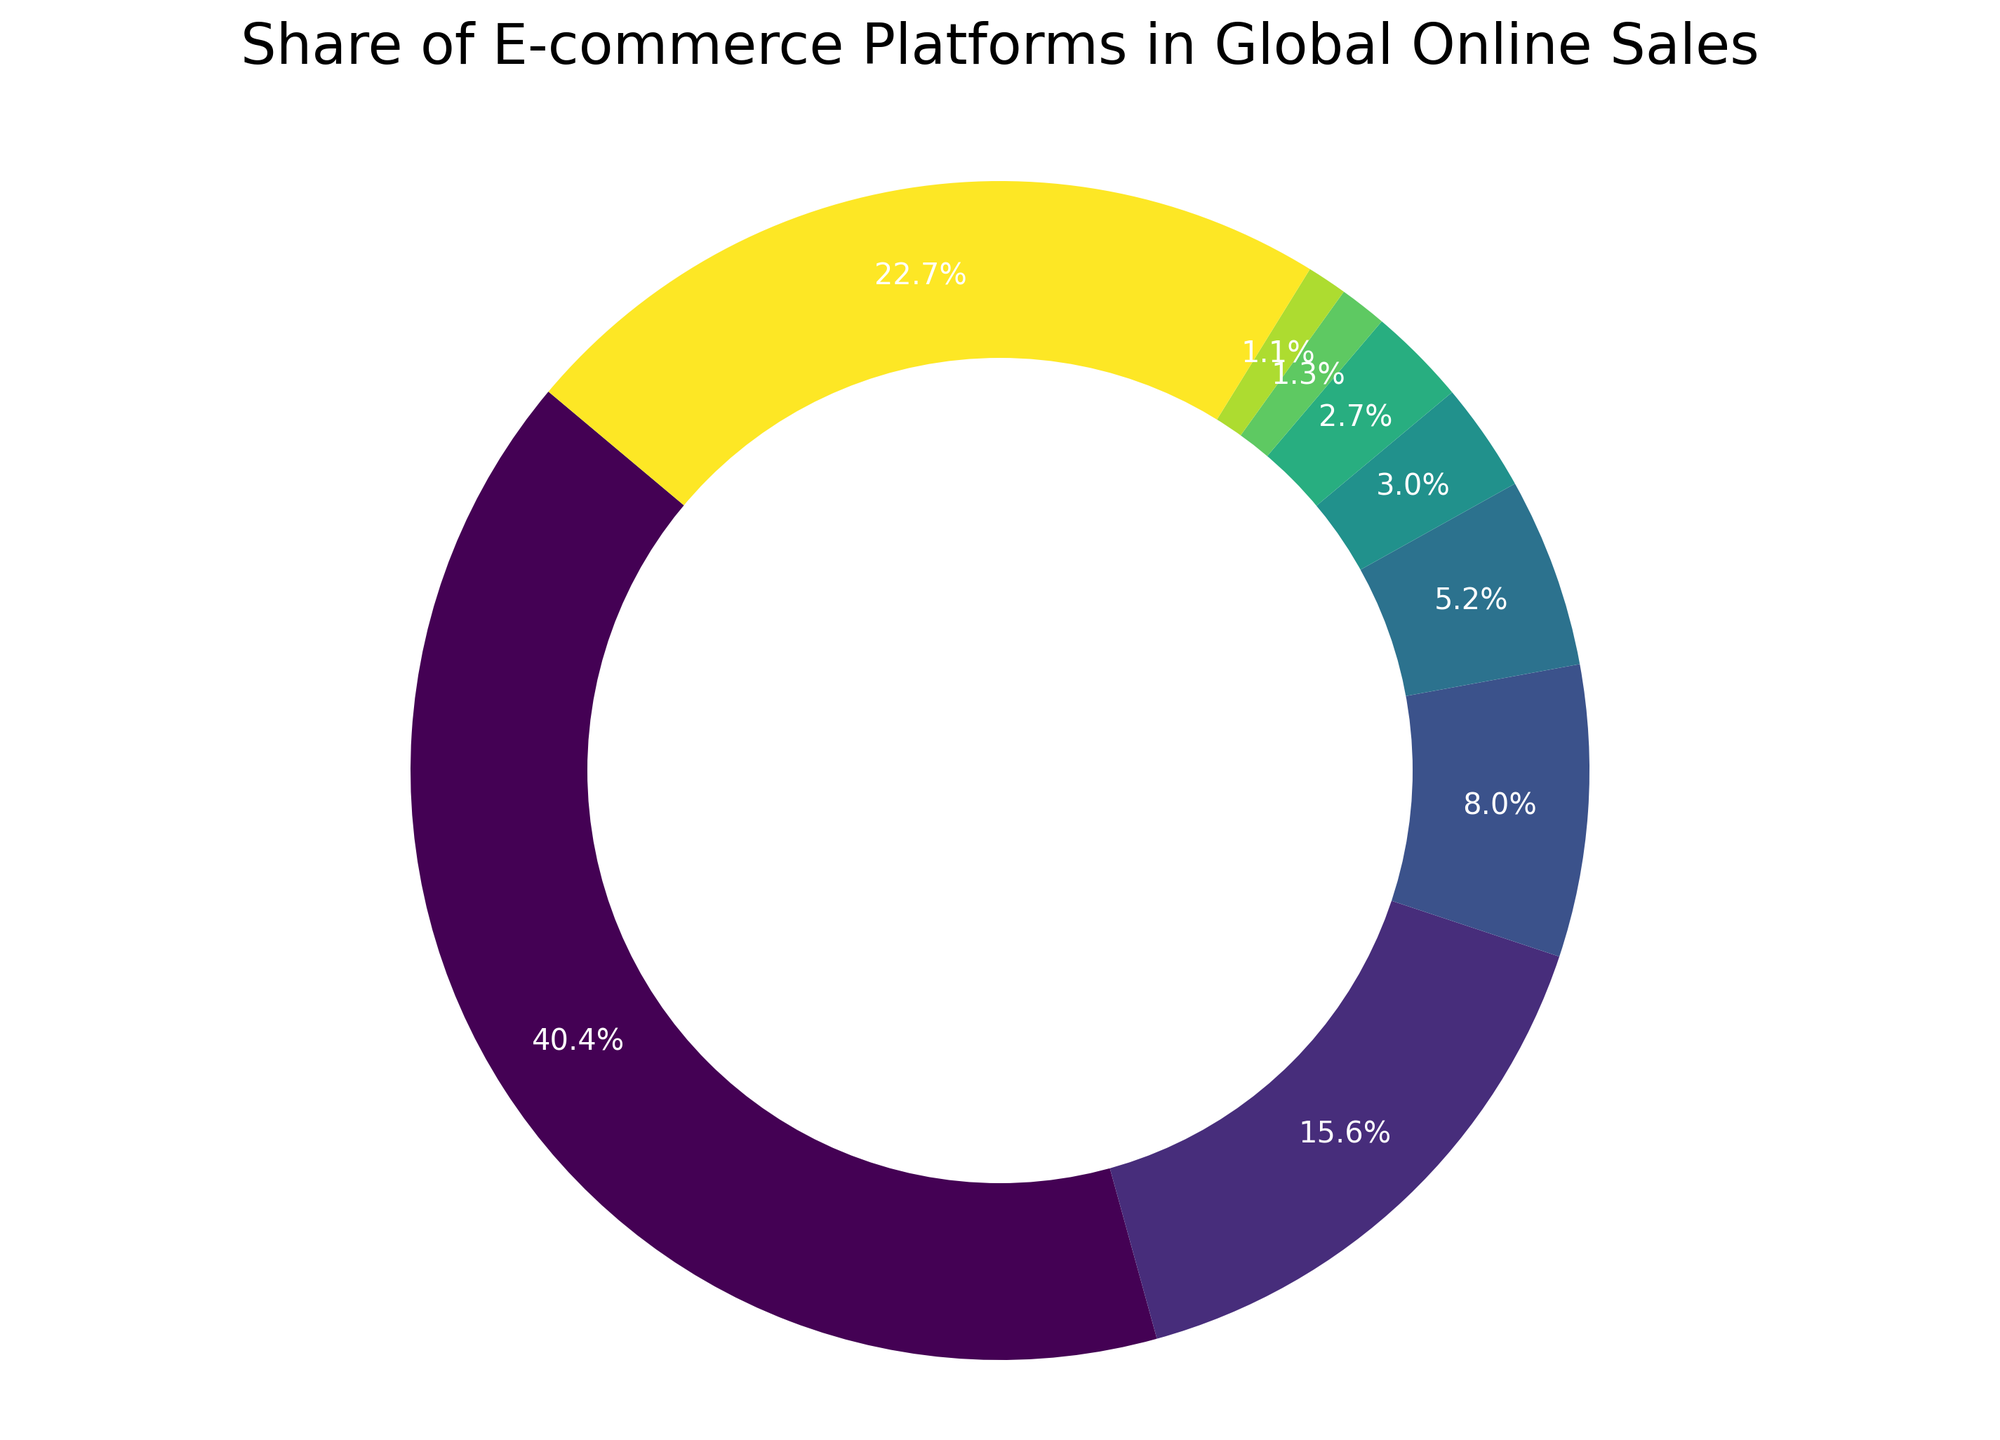How much larger is Amazon's share compared to Alibaba's share? Amazon's share is 40.4%, and Alibaba's share is 15.6%. The difference is calculated as 40.4% - 15.6% = 24.8%.
Answer: 24.8% What is the combined share of JD.com, eBay, and Shopify in global online sales? JD.com's share is 8.0%, eBay's share is 5.2%, and Shopify's share is 3.0%. The combined share is 8.0% + 5.2% + 3.0% = 16.2%.
Answer: 16.2% Which platform has the smallest share in global online sales, and what is that share? Looking at the pie chart, Mercado Libre has the smallest share with 1.1%.
Answer: Mercado Libre, 1.1% Is Amazon's share more than the combined share of Alibaba and JD.com? Amazon's share is 40.4%. Alibaba's share is 15.6%, and JD.com's share is 8.0%. Their combined share is 15.6% + 8.0% = 23.6%. Since 40.4% is greater than 23.6%, Amazon's share is more.
Answer: Yes What proportion of the global online sales do the platforms labeled 'Others' represent? The ‘Others’ platform has a share of 22.7% as indicated in the chart.
Answer: 22.7% If you sum up the shares of Walmart and Rakuten, how does it compare to the share of eBay? Is it more or less? Walmart's share is 2.7%, and Rakuten's share is 1.3%. Their combined share is 2.7% + 1.3% = 4.0%. eBay's share is 5.2%. Since 4.0% is less than 5.2%, their combined share is less.
Answer: Less What is the average share of Amazon, Alibaba, and JD.com? The shares are Amazon: 40.4%, Alibaba: 15.6%, JD.com: 8.0%. The average is calculated as (40.4% + 15.6% + 8.0%) / 3 = 21.3%.
Answer: 21.3% Which platform's share is closest to 3%? Shopify has a share of 3.0%, which directly matches 3%.
Answer: Shopify Compare the share of Walmart and Mercado Libre. Which one is higher and by how much? Walmart's share is 2.7%, and Mercado Libre's share is 1.1%. The difference is 2.7% - 1.1% = 1.6%.
Answer: Walmart by 1.6% How does the share of 'Others' compare to the combined share of Shopify, Walmart, and Rakuten? Is it more or less? 'Others' have a share of 22.7%. The combined share of Shopify, Walmart, and Rakuten is 3.0% + 2.7% + 1.3% = 7.0%. Since 22.7% is greater than 7.0%, 'Others' have a higher share.
Answer: More 